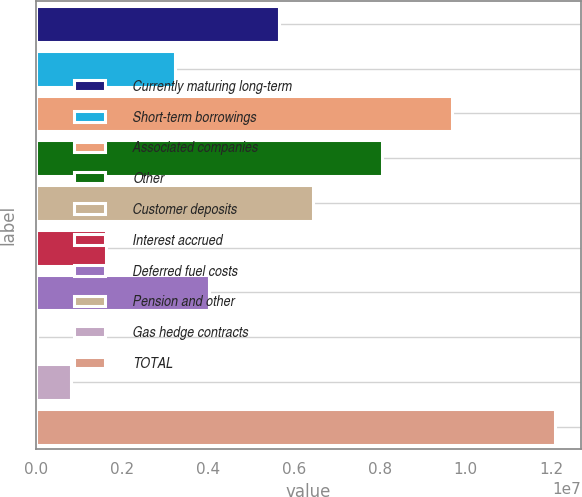<chart> <loc_0><loc_0><loc_500><loc_500><bar_chart><fcel>Currently maturing long-term<fcel>Short-term borrowings<fcel>Associated companies<fcel>Other<fcel>Customer deposits<fcel>Interest accrued<fcel>Deferred fuel costs<fcel>Pension and other<fcel>Gas hedge contracts<fcel>TOTAL<nl><fcel>5.64746e+06<fcel>3.23104e+06<fcel>9.67481e+06<fcel>8.06387e+06<fcel>6.45293e+06<fcel>1.6201e+06<fcel>4.03651e+06<fcel>9161<fcel>814632<fcel>1.20912e+07<nl></chart> 